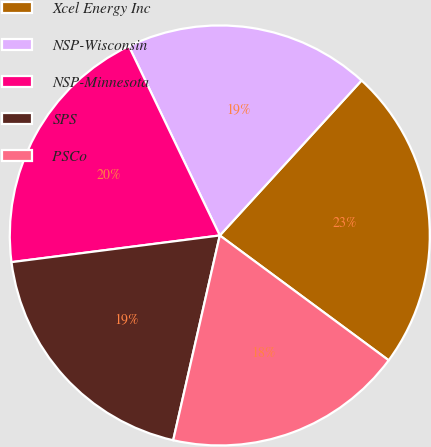Convert chart. <chart><loc_0><loc_0><loc_500><loc_500><pie_chart><fcel>Xcel Energy Inc<fcel>NSP-Wisconsin<fcel>NSP-Minnesota<fcel>SPS<fcel>PSCo<nl><fcel>23.34%<fcel>18.92%<fcel>19.9%<fcel>19.41%<fcel>18.43%<nl></chart> 